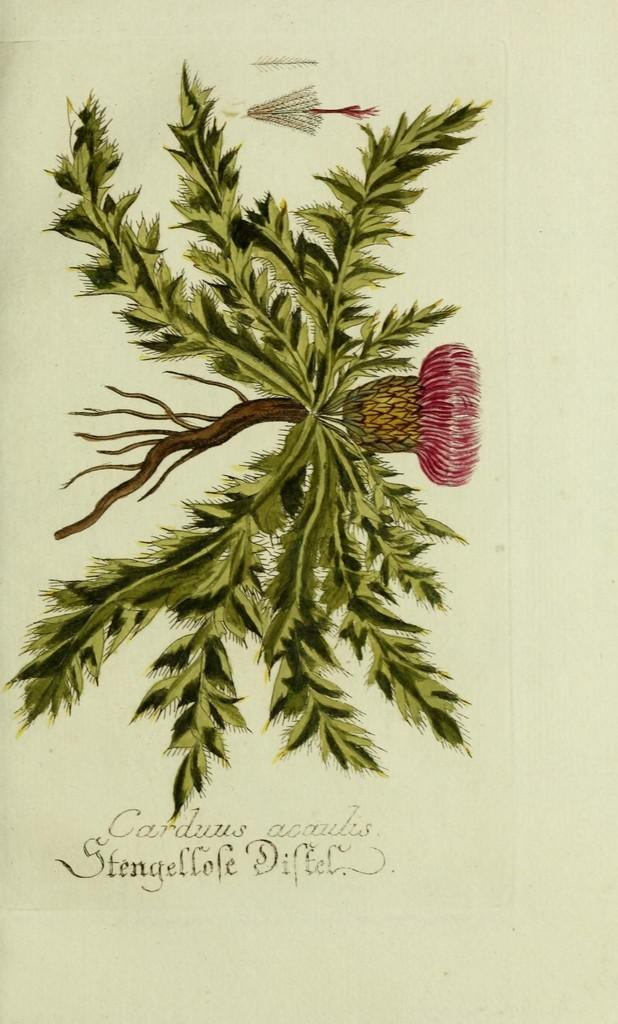What is depicted in the printed image in the picture? There is a printed image of a plant with a flower in the picture. What else can be seen at the bottom of the picture? There is text at the bottom of the picture. What type of crayon can be seen in the alley next to the trucks in the image? There is no crayon, alley, or trucks present in the image. 